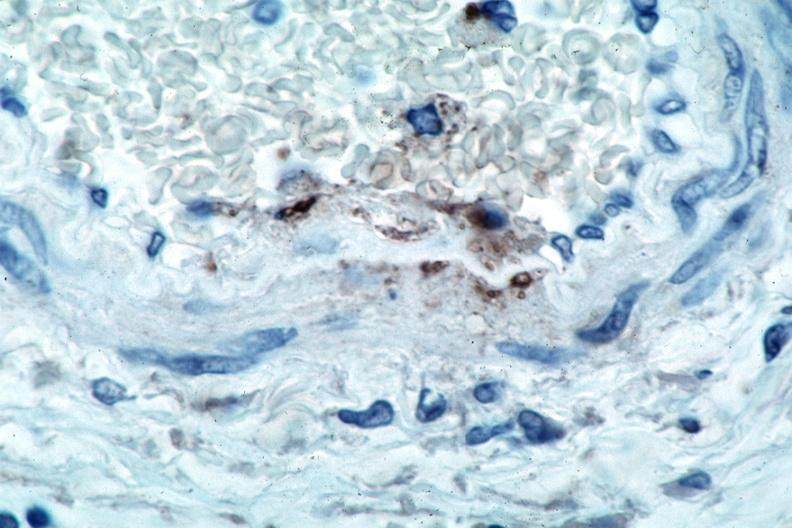s cardiovascular present?
Answer the question using a single word or phrase. Yes 